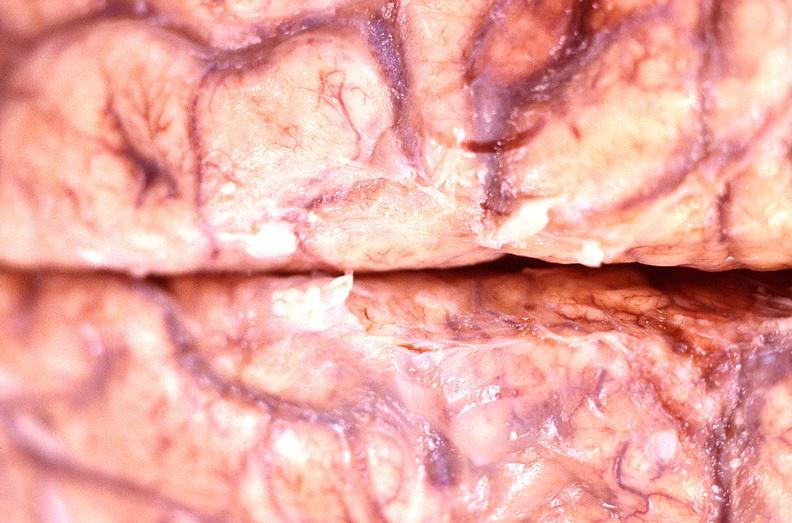s nervous present?
Answer the question using a single word or phrase. Yes 